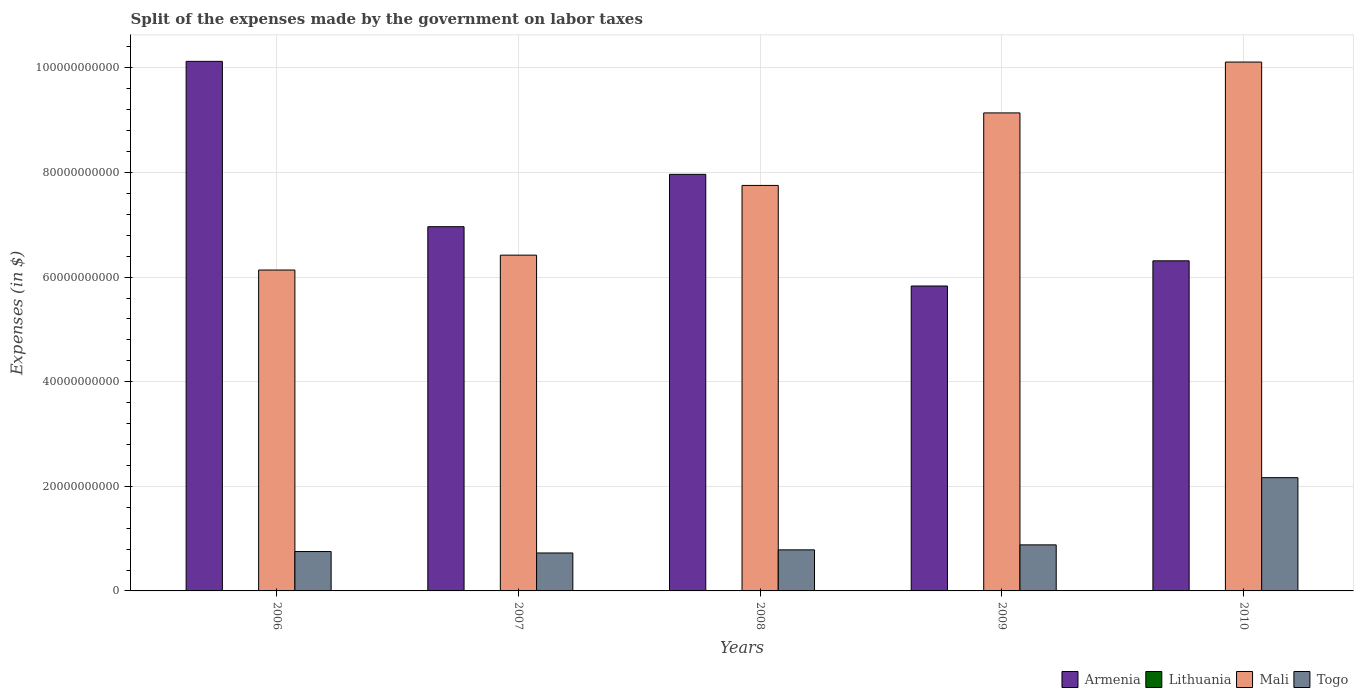Are the number of bars on each tick of the X-axis equal?
Ensure brevity in your answer.  Yes. What is the expenses made by the government on labor taxes in Armenia in 2010?
Your response must be concise. 6.31e+1. Across all years, what is the maximum expenses made by the government on labor taxes in Lithuania?
Offer a terse response. 3.97e+07. Across all years, what is the minimum expenses made by the government on labor taxes in Lithuania?
Your answer should be very brief. 1.65e+07. What is the total expenses made by the government on labor taxes in Armenia in the graph?
Make the answer very short. 3.72e+11. What is the difference between the expenses made by the government on labor taxes in Togo in 2006 and that in 2010?
Make the answer very short. -1.41e+1. What is the difference between the expenses made by the government on labor taxes in Armenia in 2007 and the expenses made by the government on labor taxes in Togo in 2006?
Your response must be concise. 6.21e+1. What is the average expenses made by the government on labor taxes in Lithuania per year?
Provide a short and direct response. 2.91e+07. In the year 2010, what is the difference between the expenses made by the government on labor taxes in Togo and expenses made by the government on labor taxes in Lithuania?
Offer a terse response. 2.16e+1. In how many years, is the expenses made by the government on labor taxes in Lithuania greater than 56000000000 $?
Give a very brief answer. 0. What is the ratio of the expenses made by the government on labor taxes in Armenia in 2009 to that in 2010?
Your answer should be very brief. 0.92. What is the difference between the highest and the second highest expenses made by the government on labor taxes in Lithuania?
Your response must be concise. 1.50e+06. What is the difference between the highest and the lowest expenses made by the government on labor taxes in Mali?
Keep it short and to the point. 3.98e+1. In how many years, is the expenses made by the government on labor taxes in Lithuania greater than the average expenses made by the government on labor taxes in Lithuania taken over all years?
Offer a terse response. 3. Is the sum of the expenses made by the government on labor taxes in Togo in 2006 and 2009 greater than the maximum expenses made by the government on labor taxes in Mali across all years?
Make the answer very short. No. Is it the case that in every year, the sum of the expenses made by the government on labor taxes in Togo and expenses made by the government on labor taxes in Lithuania is greater than the sum of expenses made by the government on labor taxes in Mali and expenses made by the government on labor taxes in Armenia?
Your answer should be very brief. Yes. What does the 1st bar from the left in 2006 represents?
Keep it short and to the point. Armenia. What does the 3rd bar from the right in 2008 represents?
Provide a succinct answer. Lithuania. Is it the case that in every year, the sum of the expenses made by the government on labor taxes in Mali and expenses made by the government on labor taxes in Lithuania is greater than the expenses made by the government on labor taxes in Togo?
Keep it short and to the point. Yes. Are all the bars in the graph horizontal?
Give a very brief answer. No. How many years are there in the graph?
Your answer should be very brief. 5. Are the values on the major ticks of Y-axis written in scientific E-notation?
Offer a terse response. No. Where does the legend appear in the graph?
Keep it short and to the point. Bottom right. What is the title of the graph?
Offer a terse response. Split of the expenses made by the government on labor taxes. What is the label or title of the X-axis?
Give a very brief answer. Years. What is the label or title of the Y-axis?
Offer a terse response. Expenses (in $). What is the Expenses (in $) of Armenia in 2006?
Give a very brief answer. 1.01e+11. What is the Expenses (in $) in Lithuania in 2006?
Your answer should be very brief. 3.21e+07. What is the Expenses (in $) of Mali in 2006?
Provide a short and direct response. 6.14e+1. What is the Expenses (in $) of Togo in 2006?
Make the answer very short. 7.53e+09. What is the Expenses (in $) of Armenia in 2007?
Make the answer very short. 6.96e+1. What is the Expenses (in $) of Lithuania in 2007?
Provide a short and direct response. 3.97e+07. What is the Expenses (in $) in Mali in 2007?
Provide a succinct answer. 6.42e+1. What is the Expenses (in $) of Togo in 2007?
Provide a succinct answer. 7.26e+09. What is the Expenses (in $) in Armenia in 2008?
Make the answer very short. 7.97e+1. What is the Expenses (in $) of Lithuania in 2008?
Provide a short and direct response. 3.82e+07. What is the Expenses (in $) in Mali in 2008?
Give a very brief answer. 7.75e+1. What is the Expenses (in $) in Togo in 2008?
Your answer should be compact. 7.85e+09. What is the Expenses (in $) of Armenia in 2009?
Offer a terse response. 5.83e+1. What is the Expenses (in $) of Lithuania in 2009?
Offer a terse response. 1.90e+07. What is the Expenses (in $) of Mali in 2009?
Make the answer very short. 9.14e+1. What is the Expenses (in $) in Togo in 2009?
Make the answer very short. 8.80e+09. What is the Expenses (in $) of Armenia in 2010?
Provide a short and direct response. 6.31e+1. What is the Expenses (in $) of Lithuania in 2010?
Your answer should be very brief. 1.65e+07. What is the Expenses (in $) of Mali in 2010?
Make the answer very short. 1.01e+11. What is the Expenses (in $) of Togo in 2010?
Offer a very short reply. 2.17e+1. Across all years, what is the maximum Expenses (in $) of Armenia?
Provide a short and direct response. 1.01e+11. Across all years, what is the maximum Expenses (in $) of Lithuania?
Offer a terse response. 3.97e+07. Across all years, what is the maximum Expenses (in $) in Mali?
Offer a terse response. 1.01e+11. Across all years, what is the maximum Expenses (in $) of Togo?
Provide a succinct answer. 2.17e+1. Across all years, what is the minimum Expenses (in $) of Armenia?
Offer a terse response. 5.83e+1. Across all years, what is the minimum Expenses (in $) of Lithuania?
Offer a very short reply. 1.65e+07. Across all years, what is the minimum Expenses (in $) of Mali?
Provide a short and direct response. 6.14e+1. Across all years, what is the minimum Expenses (in $) of Togo?
Offer a very short reply. 7.26e+09. What is the total Expenses (in $) of Armenia in the graph?
Your answer should be very brief. 3.72e+11. What is the total Expenses (in $) of Lithuania in the graph?
Offer a very short reply. 1.46e+08. What is the total Expenses (in $) in Mali in the graph?
Make the answer very short. 3.96e+11. What is the total Expenses (in $) of Togo in the graph?
Keep it short and to the point. 5.31e+1. What is the difference between the Expenses (in $) in Armenia in 2006 and that in 2007?
Make the answer very short. 3.16e+1. What is the difference between the Expenses (in $) in Lithuania in 2006 and that in 2007?
Keep it short and to the point. -7.60e+06. What is the difference between the Expenses (in $) of Mali in 2006 and that in 2007?
Make the answer very short. -2.84e+09. What is the difference between the Expenses (in $) of Togo in 2006 and that in 2007?
Offer a terse response. 2.73e+08. What is the difference between the Expenses (in $) in Armenia in 2006 and that in 2008?
Give a very brief answer. 2.16e+1. What is the difference between the Expenses (in $) in Lithuania in 2006 and that in 2008?
Keep it short and to the point. -6.10e+06. What is the difference between the Expenses (in $) of Mali in 2006 and that in 2008?
Your response must be concise. -1.62e+1. What is the difference between the Expenses (in $) of Togo in 2006 and that in 2008?
Provide a succinct answer. -3.23e+08. What is the difference between the Expenses (in $) in Armenia in 2006 and that in 2009?
Give a very brief answer. 4.30e+1. What is the difference between the Expenses (in $) in Lithuania in 2006 and that in 2009?
Your answer should be very brief. 1.31e+07. What is the difference between the Expenses (in $) in Mali in 2006 and that in 2009?
Ensure brevity in your answer.  -3.00e+1. What is the difference between the Expenses (in $) in Togo in 2006 and that in 2009?
Your answer should be compact. -1.28e+09. What is the difference between the Expenses (in $) in Armenia in 2006 and that in 2010?
Provide a short and direct response. 3.81e+1. What is the difference between the Expenses (in $) in Lithuania in 2006 and that in 2010?
Your answer should be compact. 1.56e+07. What is the difference between the Expenses (in $) of Mali in 2006 and that in 2010?
Your answer should be compact. -3.98e+1. What is the difference between the Expenses (in $) in Togo in 2006 and that in 2010?
Offer a very short reply. -1.41e+1. What is the difference between the Expenses (in $) of Armenia in 2007 and that in 2008?
Your answer should be compact. -1.00e+1. What is the difference between the Expenses (in $) in Lithuania in 2007 and that in 2008?
Provide a succinct answer. 1.50e+06. What is the difference between the Expenses (in $) in Mali in 2007 and that in 2008?
Offer a terse response. -1.33e+1. What is the difference between the Expenses (in $) in Togo in 2007 and that in 2008?
Your answer should be compact. -5.96e+08. What is the difference between the Expenses (in $) in Armenia in 2007 and that in 2009?
Make the answer very short. 1.13e+1. What is the difference between the Expenses (in $) in Lithuania in 2007 and that in 2009?
Ensure brevity in your answer.  2.07e+07. What is the difference between the Expenses (in $) in Mali in 2007 and that in 2009?
Give a very brief answer. -2.72e+1. What is the difference between the Expenses (in $) of Togo in 2007 and that in 2009?
Your answer should be compact. -1.55e+09. What is the difference between the Expenses (in $) of Armenia in 2007 and that in 2010?
Your answer should be very brief. 6.53e+09. What is the difference between the Expenses (in $) of Lithuania in 2007 and that in 2010?
Give a very brief answer. 2.32e+07. What is the difference between the Expenses (in $) in Mali in 2007 and that in 2010?
Your response must be concise. -3.69e+1. What is the difference between the Expenses (in $) of Togo in 2007 and that in 2010?
Provide a succinct answer. -1.44e+1. What is the difference between the Expenses (in $) in Armenia in 2008 and that in 2009?
Make the answer very short. 2.14e+1. What is the difference between the Expenses (in $) in Lithuania in 2008 and that in 2009?
Offer a terse response. 1.92e+07. What is the difference between the Expenses (in $) in Mali in 2008 and that in 2009?
Keep it short and to the point. -1.39e+1. What is the difference between the Expenses (in $) in Togo in 2008 and that in 2009?
Make the answer very short. -9.53e+08. What is the difference between the Expenses (in $) of Armenia in 2008 and that in 2010?
Provide a succinct answer. 1.65e+1. What is the difference between the Expenses (in $) of Lithuania in 2008 and that in 2010?
Make the answer very short. 2.17e+07. What is the difference between the Expenses (in $) of Mali in 2008 and that in 2010?
Your answer should be very brief. -2.36e+1. What is the difference between the Expenses (in $) of Togo in 2008 and that in 2010?
Your response must be concise. -1.38e+1. What is the difference between the Expenses (in $) in Armenia in 2009 and that in 2010?
Keep it short and to the point. -4.82e+09. What is the difference between the Expenses (in $) in Lithuania in 2009 and that in 2010?
Offer a terse response. 2.50e+06. What is the difference between the Expenses (in $) in Mali in 2009 and that in 2010?
Your answer should be very brief. -9.72e+09. What is the difference between the Expenses (in $) of Togo in 2009 and that in 2010?
Give a very brief answer. -1.28e+1. What is the difference between the Expenses (in $) of Armenia in 2006 and the Expenses (in $) of Lithuania in 2007?
Make the answer very short. 1.01e+11. What is the difference between the Expenses (in $) of Armenia in 2006 and the Expenses (in $) of Mali in 2007?
Ensure brevity in your answer.  3.71e+1. What is the difference between the Expenses (in $) of Armenia in 2006 and the Expenses (in $) of Togo in 2007?
Give a very brief answer. 9.40e+1. What is the difference between the Expenses (in $) in Lithuania in 2006 and the Expenses (in $) in Mali in 2007?
Ensure brevity in your answer.  -6.42e+1. What is the difference between the Expenses (in $) in Lithuania in 2006 and the Expenses (in $) in Togo in 2007?
Give a very brief answer. -7.22e+09. What is the difference between the Expenses (in $) in Mali in 2006 and the Expenses (in $) in Togo in 2007?
Your answer should be compact. 5.41e+1. What is the difference between the Expenses (in $) in Armenia in 2006 and the Expenses (in $) in Lithuania in 2008?
Make the answer very short. 1.01e+11. What is the difference between the Expenses (in $) of Armenia in 2006 and the Expenses (in $) of Mali in 2008?
Provide a succinct answer. 2.37e+1. What is the difference between the Expenses (in $) of Armenia in 2006 and the Expenses (in $) of Togo in 2008?
Provide a succinct answer. 9.34e+1. What is the difference between the Expenses (in $) of Lithuania in 2006 and the Expenses (in $) of Mali in 2008?
Keep it short and to the point. -7.75e+1. What is the difference between the Expenses (in $) in Lithuania in 2006 and the Expenses (in $) in Togo in 2008?
Ensure brevity in your answer.  -7.82e+09. What is the difference between the Expenses (in $) in Mali in 2006 and the Expenses (in $) in Togo in 2008?
Provide a short and direct response. 5.35e+1. What is the difference between the Expenses (in $) in Armenia in 2006 and the Expenses (in $) in Lithuania in 2009?
Keep it short and to the point. 1.01e+11. What is the difference between the Expenses (in $) in Armenia in 2006 and the Expenses (in $) in Mali in 2009?
Give a very brief answer. 9.86e+09. What is the difference between the Expenses (in $) in Armenia in 2006 and the Expenses (in $) in Togo in 2009?
Your response must be concise. 9.24e+1. What is the difference between the Expenses (in $) of Lithuania in 2006 and the Expenses (in $) of Mali in 2009?
Your response must be concise. -9.14e+1. What is the difference between the Expenses (in $) of Lithuania in 2006 and the Expenses (in $) of Togo in 2009?
Provide a short and direct response. -8.77e+09. What is the difference between the Expenses (in $) of Mali in 2006 and the Expenses (in $) of Togo in 2009?
Your answer should be very brief. 5.26e+1. What is the difference between the Expenses (in $) in Armenia in 2006 and the Expenses (in $) in Lithuania in 2010?
Your answer should be very brief. 1.01e+11. What is the difference between the Expenses (in $) in Armenia in 2006 and the Expenses (in $) in Mali in 2010?
Provide a short and direct response. 1.33e+08. What is the difference between the Expenses (in $) of Armenia in 2006 and the Expenses (in $) of Togo in 2010?
Your answer should be compact. 7.96e+1. What is the difference between the Expenses (in $) of Lithuania in 2006 and the Expenses (in $) of Mali in 2010?
Provide a short and direct response. -1.01e+11. What is the difference between the Expenses (in $) in Lithuania in 2006 and the Expenses (in $) in Togo in 2010?
Provide a succinct answer. -2.16e+1. What is the difference between the Expenses (in $) in Mali in 2006 and the Expenses (in $) in Togo in 2010?
Ensure brevity in your answer.  3.97e+1. What is the difference between the Expenses (in $) of Armenia in 2007 and the Expenses (in $) of Lithuania in 2008?
Your answer should be very brief. 6.96e+1. What is the difference between the Expenses (in $) in Armenia in 2007 and the Expenses (in $) in Mali in 2008?
Offer a very short reply. -7.89e+09. What is the difference between the Expenses (in $) in Armenia in 2007 and the Expenses (in $) in Togo in 2008?
Your response must be concise. 6.18e+1. What is the difference between the Expenses (in $) in Lithuania in 2007 and the Expenses (in $) in Mali in 2008?
Provide a short and direct response. -7.75e+1. What is the difference between the Expenses (in $) of Lithuania in 2007 and the Expenses (in $) of Togo in 2008?
Offer a terse response. -7.81e+09. What is the difference between the Expenses (in $) in Mali in 2007 and the Expenses (in $) in Togo in 2008?
Give a very brief answer. 5.63e+1. What is the difference between the Expenses (in $) in Armenia in 2007 and the Expenses (in $) in Lithuania in 2009?
Offer a terse response. 6.96e+1. What is the difference between the Expenses (in $) in Armenia in 2007 and the Expenses (in $) in Mali in 2009?
Your answer should be very brief. -2.18e+1. What is the difference between the Expenses (in $) in Armenia in 2007 and the Expenses (in $) in Togo in 2009?
Your answer should be compact. 6.08e+1. What is the difference between the Expenses (in $) of Lithuania in 2007 and the Expenses (in $) of Mali in 2009?
Your answer should be compact. -9.14e+1. What is the difference between the Expenses (in $) of Lithuania in 2007 and the Expenses (in $) of Togo in 2009?
Provide a short and direct response. -8.77e+09. What is the difference between the Expenses (in $) of Mali in 2007 and the Expenses (in $) of Togo in 2009?
Your answer should be very brief. 5.54e+1. What is the difference between the Expenses (in $) of Armenia in 2007 and the Expenses (in $) of Lithuania in 2010?
Offer a very short reply. 6.96e+1. What is the difference between the Expenses (in $) in Armenia in 2007 and the Expenses (in $) in Mali in 2010?
Offer a very short reply. -3.15e+1. What is the difference between the Expenses (in $) in Armenia in 2007 and the Expenses (in $) in Togo in 2010?
Provide a succinct answer. 4.80e+1. What is the difference between the Expenses (in $) in Lithuania in 2007 and the Expenses (in $) in Mali in 2010?
Your answer should be very brief. -1.01e+11. What is the difference between the Expenses (in $) of Lithuania in 2007 and the Expenses (in $) of Togo in 2010?
Ensure brevity in your answer.  -2.16e+1. What is the difference between the Expenses (in $) in Mali in 2007 and the Expenses (in $) in Togo in 2010?
Your answer should be very brief. 4.25e+1. What is the difference between the Expenses (in $) in Armenia in 2008 and the Expenses (in $) in Lithuania in 2009?
Provide a short and direct response. 7.96e+1. What is the difference between the Expenses (in $) of Armenia in 2008 and the Expenses (in $) of Mali in 2009?
Give a very brief answer. -1.17e+1. What is the difference between the Expenses (in $) in Armenia in 2008 and the Expenses (in $) in Togo in 2009?
Your answer should be compact. 7.08e+1. What is the difference between the Expenses (in $) in Lithuania in 2008 and the Expenses (in $) in Mali in 2009?
Your response must be concise. -9.14e+1. What is the difference between the Expenses (in $) in Lithuania in 2008 and the Expenses (in $) in Togo in 2009?
Keep it short and to the point. -8.77e+09. What is the difference between the Expenses (in $) of Mali in 2008 and the Expenses (in $) of Togo in 2009?
Your answer should be compact. 6.87e+1. What is the difference between the Expenses (in $) in Armenia in 2008 and the Expenses (in $) in Lithuania in 2010?
Your response must be concise. 7.96e+1. What is the difference between the Expenses (in $) of Armenia in 2008 and the Expenses (in $) of Mali in 2010?
Provide a short and direct response. -2.15e+1. What is the difference between the Expenses (in $) in Armenia in 2008 and the Expenses (in $) in Togo in 2010?
Give a very brief answer. 5.80e+1. What is the difference between the Expenses (in $) in Lithuania in 2008 and the Expenses (in $) in Mali in 2010?
Keep it short and to the point. -1.01e+11. What is the difference between the Expenses (in $) of Lithuania in 2008 and the Expenses (in $) of Togo in 2010?
Your answer should be compact. -2.16e+1. What is the difference between the Expenses (in $) in Mali in 2008 and the Expenses (in $) in Togo in 2010?
Your answer should be compact. 5.59e+1. What is the difference between the Expenses (in $) in Armenia in 2009 and the Expenses (in $) in Lithuania in 2010?
Provide a succinct answer. 5.83e+1. What is the difference between the Expenses (in $) in Armenia in 2009 and the Expenses (in $) in Mali in 2010?
Provide a succinct answer. -4.28e+1. What is the difference between the Expenses (in $) in Armenia in 2009 and the Expenses (in $) in Togo in 2010?
Make the answer very short. 3.66e+1. What is the difference between the Expenses (in $) of Lithuania in 2009 and the Expenses (in $) of Mali in 2010?
Provide a succinct answer. -1.01e+11. What is the difference between the Expenses (in $) in Lithuania in 2009 and the Expenses (in $) in Togo in 2010?
Offer a terse response. -2.16e+1. What is the difference between the Expenses (in $) in Mali in 2009 and the Expenses (in $) in Togo in 2010?
Give a very brief answer. 6.97e+1. What is the average Expenses (in $) of Armenia per year?
Your response must be concise. 7.44e+1. What is the average Expenses (in $) of Lithuania per year?
Offer a terse response. 2.91e+07. What is the average Expenses (in $) in Mali per year?
Provide a short and direct response. 7.91e+1. What is the average Expenses (in $) of Togo per year?
Keep it short and to the point. 1.06e+1. In the year 2006, what is the difference between the Expenses (in $) in Armenia and Expenses (in $) in Lithuania?
Offer a terse response. 1.01e+11. In the year 2006, what is the difference between the Expenses (in $) in Armenia and Expenses (in $) in Mali?
Ensure brevity in your answer.  3.99e+1. In the year 2006, what is the difference between the Expenses (in $) of Armenia and Expenses (in $) of Togo?
Make the answer very short. 9.37e+1. In the year 2006, what is the difference between the Expenses (in $) in Lithuania and Expenses (in $) in Mali?
Your answer should be compact. -6.13e+1. In the year 2006, what is the difference between the Expenses (in $) in Lithuania and Expenses (in $) in Togo?
Keep it short and to the point. -7.50e+09. In the year 2006, what is the difference between the Expenses (in $) of Mali and Expenses (in $) of Togo?
Provide a succinct answer. 5.38e+1. In the year 2007, what is the difference between the Expenses (in $) in Armenia and Expenses (in $) in Lithuania?
Offer a very short reply. 6.96e+1. In the year 2007, what is the difference between the Expenses (in $) of Armenia and Expenses (in $) of Mali?
Provide a succinct answer. 5.44e+09. In the year 2007, what is the difference between the Expenses (in $) of Armenia and Expenses (in $) of Togo?
Make the answer very short. 6.24e+1. In the year 2007, what is the difference between the Expenses (in $) of Lithuania and Expenses (in $) of Mali?
Your answer should be very brief. -6.42e+1. In the year 2007, what is the difference between the Expenses (in $) in Lithuania and Expenses (in $) in Togo?
Make the answer very short. -7.22e+09. In the year 2007, what is the difference between the Expenses (in $) of Mali and Expenses (in $) of Togo?
Give a very brief answer. 5.69e+1. In the year 2008, what is the difference between the Expenses (in $) in Armenia and Expenses (in $) in Lithuania?
Offer a very short reply. 7.96e+1. In the year 2008, what is the difference between the Expenses (in $) of Armenia and Expenses (in $) of Mali?
Your response must be concise. 2.12e+09. In the year 2008, what is the difference between the Expenses (in $) of Armenia and Expenses (in $) of Togo?
Provide a short and direct response. 7.18e+1. In the year 2008, what is the difference between the Expenses (in $) in Lithuania and Expenses (in $) in Mali?
Keep it short and to the point. -7.75e+1. In the year 2008, what is the difference between the Expenses (in $) of Lithuania and Expenses (in $) of Togo?
Ensure brevity in your answer.  -7.81e+09. In the year 2008, what is the difference between the Expenses (in $) of Mali and Expenses (in $) of Togo?
Offer a very short reply. 6.97e+1. In the year 2009, what is the difference between the Expenses (in $) of Armenia and Expenses (in $) of Lithuania?
Provide a succinct answer. 5.83e+1. In the year 2009, what is the difference between the Expenses (in $) of Armenia and Expenses (in $) of Mali?
Make the answer very short. -3.31e+1. In the year 2009, what is the difference between the Expenses (in $) of Armenia and Expenses (in $) of Togo?
Make the answer very short. 4.95e+1. In the year 2009, what is the difference between the Expenses (in $) in Lithuania and Expenses (in $) in Mali?
Offer a very short reply. -9.14e+1. In the year 2009, what is the difference between the Expenses (in $) in Lithuania and Expenses (in $) in Togo?
Make the answer very short. -8.79e+09. In the year 2009, what is the difference between the Expenses (in $) in Mali and Expenses (in $) in Togo?
Ensure brevity in your answer.  8.26e+1. In the year 2010, what is the difference between the Expenses (in $) in Armenia and Expenses (in $) in Lithuania?
Provide a succinct answer. 6.31e+1. In the year 2010, what is the difference between the Expenses (in $) of Armenia and Expenses (in $) of Mali?
Offer a terse response. -3.80e+1. In the year 2010, what is the difference between the Expenses (in $) of Armenia and Expenses (in $) of Togo?
Give a very brief answer. 4.15e+1. In the year 2010, what is the difference between the Expenses (in $) of Lithuania and Expenses (in $) of Mali?
Offer a very short reply. -1.01e+11. In the year 2010, what is the difference between the Expenses (in $) of Lithuania and Expenses (in $) of Togo?
Offer a terse response. -2.16e+1. In the year 2010, what is the difference between the Expenses (in $) of Mali and Expenses (in $) of Togo?
Your answer should be very brief. 7.95e+1. What is the ratio of the Expenses (in $) of Armenia in 2006 to that in 2007?
Your answer should be compact. 1.45. What is the ratio of the Expenses (in $) of Lithuania in 2006 to that in 2007?
Ensure brevity in your answer.  0.81. What is the ratio of the Expenses (in $) of Mali in 2006 to that in 2007?
Give a very brief answer. 0.96. What is the ratio of the Expenses (in $) of Togo in 2006 to that in 2007?
Give a very brief answer. 1.04. What is the ratio of the Expenses (in $) in Armenia in 2006 to that in 2008?
Your answer should be very brief. 1.27. What is the ratio of the Expenses (in $) in Lithuania in 2006 to that in 2008?
Your response must be concise. 0.84. What is the ratio of the Expenses (in $) in Mali in 2006 to that in 2008?
Your answer should be compact. 0.79. What is the ratio of the Expenses (in $) in Togo in 2006 to that in 2008?
Offer a terse response. 0.96. What is the ratio of the Expenses (in $) in Armenia in 2006 to that in 2009?
Make the answer very short. 1.74. What is the ratio of the Expenses (in $) in Lithuania in 2006 to that in 2009?
Your answer should be compact. 1.69. What is the ratio of the Expenses (in $) in Mali in 2006 to that in 2009?
Your answer should be compact. 0.67. What is the ratio of the Expenses (in $) in Togo in 2006 to that in 2009?
Give a very brief answer. 0.86. What is the ratio of the Expenses (in $) of Armenia in 2006 to that in 2010?
Provide a short and direct response. 1.6. What is the ratio of the Expenses (in $) of Lithuania in 2006 to that in 2010?
Your answer should be compact. 1.95. What is the ratio of the Expenses (in $) of Mali in 2006 to that in 2010?
Keep it short and to the point. 0.61. What is the ratio of the Expenses (in $) of Togo in 2006 to that in 2010?
Ensure brevity in your answer.  0.35. What is the ratio of the Expenses (in $) of Armenia in 2007 to that in 2008?
Keep it short and to the point. 0.87. What is the ratio of the Expenses (in $) in Lithuania in 2007 to that in 2008?
Give a very brief answer. 1.04. What is the ratio of the Expenses (in $) in Mali in 2007 to that in 2008?
Ensure brevity in your answer.  0.83. What is the ratio of the Expenses (in $) of Togo in 2007 to that in 2008?
Ensure brevity in your answer.  0.92. What is the ratio of the Expenses (in $) in Armenia in 2007 to that in 2009?
Offer a terse response. 1.19. What is the ratio of the Expenses (in $) of Lithuania in 2007 to that in 2009?
Provide a short and direct response. 2.09. What is the ratio of the Expenses (in $) of Mali in 2007 to that in 2009?
Provide a succinct answer. 0.7. What is the ratio of the Expenses (in $) of Togo in 2007 to that in 2009?
Make the answer very short. 0.82. What is the ratio of the Expenses (in $) of Armenia in 2007 to that in 2010?
Provide a short and direct response. 1.1. What is the ratio of the Expenses (in $) in Lithuania in 2007 to that in 2010?
Keep it short and to the point. 2.41. What is the ratio of the Expenses (in $) of Mali in 2007 to that in 2010?
Offer a very short reply. 0.63. What is the ratio of the Expenses (in $) of Togo in 2007 to that in 2010?
Offer a terse response. 0.34. What is the ratio of the Expenses (in $) in Armenia in 2008 to that in 2009?
Offer a very short reply. 1.37. What is the ratio of the Expenses (in $) in Lithuania in 2008 to that in 2009?
Make the answer very short. 2.01. What is the ratio of the Expenses (in $) of Mali in 2008 to that in 2009?
Give a very brief answer. 0.85. What is the ratio of the Expenses (in $) in Togo in 2008 to that in 2009?
Your answer should be very brief. 0.89. What is the ratio of the Expenses (in $) of Armenia in 2008 to that in 2010?
Make the answer very short. 1.26. What is the ratio of the Expenses (in $) of Lithuania in 2008 to that in 2010?
Your answer should be compact. 2.32. What is the ratio of the Expenses (in $) in Mali in 2008 to that in 2010?
Provide a short and direct response. 0.77. What is the ratio of the Expenses (in $) in Togo in 2008 to that in 2010?
Provide a succinct answer. 0.36. What is the ratio of the Expenses (in $) of Armenia in 2009 to that in 2010?
Offer a terse response. 0.92. What is the ratio of the Expenses (in $) of Lithuania in 2009 to that in 2010?
Your answer should be very brief. 1.15. What is the ratio of the Expenses (in $) in Mali in 2009 to that in 2010?
Provide a succinct answer. 0.9. What is the ratio of the Expenses (in $) of Togo in 2009 to that in 2010?
Give a very brief answer. 0.41. What is the difference between the highest and the second highest Expenses (in $) in Armenia?
Make the answer very short. 2.16e+1. What is the difference between the highest and the second highest Expenses (in $) in Lithuania?
Give a very brief answer. 1.50e+06. What is the difference between the highest and the second highest Expenses (in $) in Mali?
Offer a terse response. 9.72e+09. What is the difference between the highest and the second highest Expenses (in $) of Togo?
Provide a succinct answer. 1.28e+1. What is the difference between the highest and the lowest Expenses (in $) of Armenia?
Offer a very short reply. 4.30e+1. What is the difference between the highest and the lowest Expenses (in $) in Lithuania?
Keep it short and to the point. 2.32e+07. What is the difference between the highest and the lowest Expenses (in $) in Mali?
Your answer should be very brief. 3.98e+1. What is the difference between the highest and the lowest Expenses (in $) of Togo?
Ensure brevity in your answer.  1.44e+1. 